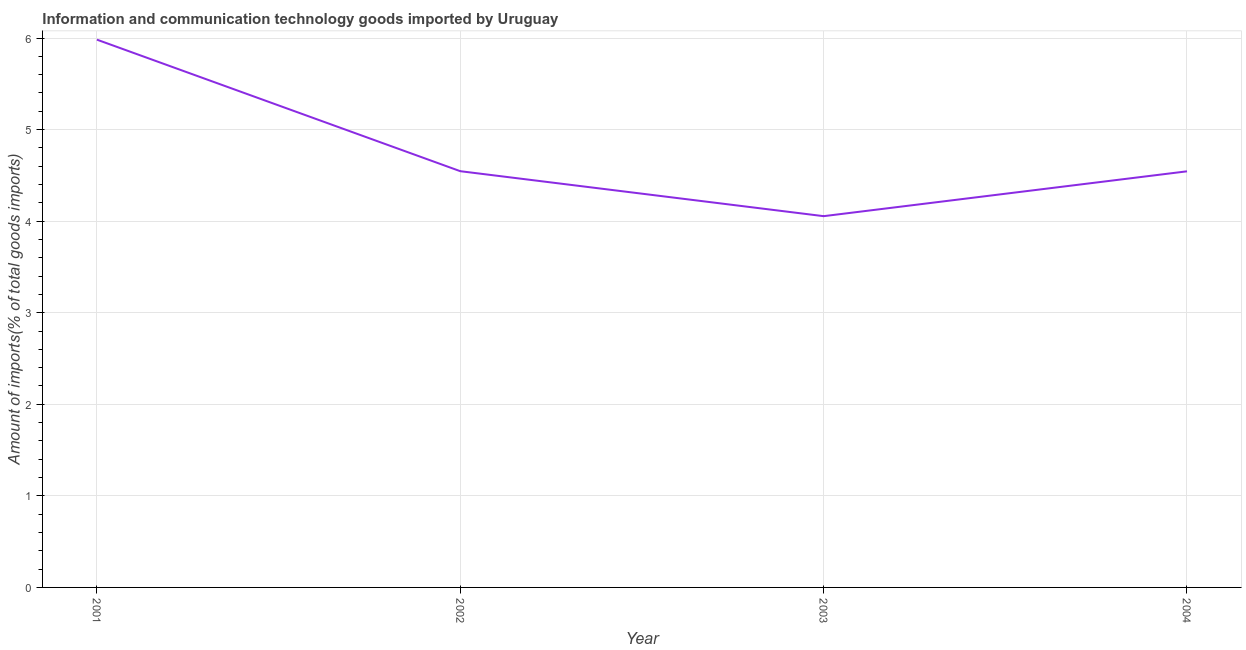What is the amount of ict goods imports in 2004?
Your response must be concise. 4.54. Across all years, what is the maximum amount of ict goods imports?
Give a very brief answer. 5.98. Across all years, what is the minimum amount of ict goods imports?
Your response must be concise. 4.05. In which year was the amount of ict goods imports minimum?
Make the answer very short. 2003. What is the sum of the amount of ict goods imports?
Make the answer very short. 19.13. What is the difference between the amount of ict goods imports in 2002 and 2004?
Your answer should be very brief. 0. What is the average amount of ict goods imports per year?
Ensure brevity in your answer.  4.78. What is the median amount of ict goods imports?
Keep it short and to the point. 4.54. In how many years, is the amount of ict goods imports greater than 4.4 %?
Your answer should be very brief. 3. What is the ratio of the amount of ict goods imports in 2001 to that in 2002?
Your answer should be compact. 1.32. Is the amount of ict goods imports in 2002 less than that in 2003?
Offer a very short reply. No. What is the difference between the highest and the second highest amount of ict goods imports?
Give a very brief answer. 1.44. What is the difference between the highest and the lowest amount of ict goods imports?
Provide a succinct answer. 1.93. In how many years, is the amount of ict goods imports greater than the average amount of ict goods imports taken over all years?
Keep it short and to the point. 1. How many lines are there?
Offer a very short reply. 1. How many years are there in the graph?
Offer a very short reply. 4. Does the graph contain any zero values?
Your answer should be very brief. No. What is the title of the graph?
Keep it short and to the point. Information and communication technology goods imported by Uruguay. What is the label or title of the X-axis?
Offer a terse response. Year. What is the label or title of the Y-axis?
Your response must be concise. Amount of imports(% of total goods imports). What is the Amount of imports(% of total goods imports) in 2001?
Provide a short and direct response. 5.98. What is the Amount of imports(% of total goods imports) of 2002?
Provide a succinct answer. 4.55. What is the Amount of imports(% of total goods imports) of 2003?
Your answer should be compact. 4.05. What is the Amount of imports(% of total goods imports) in 2004?
Your answer should be very brief. 4.54. What is the difference between the Amount of imports(% of total goods imports) in 2001 and 2002?
Ensure brevity in your answer.  1.44. What is the difference between the Amount of imports(% of total goods imports) in 2001 and 2003?
Make the answer very short. 1.93. What is the difference between the Amount of imports(% of total goods imports) in 2001 and 2004?
Offer a terse response. 1.44. What is the difference between the Amount of imports(% of total goods imports) in 2002 and 2003?
Keep it short and to the point. 0.49. What is the difference between the Amount of imports(% of total goods imports) in 2002 and 2004?
Make the answer very short. 0. What is the difference between the Amount of imports(% of total goods imports) in 2003 and 2004?
Provide a short and direct response. -0.49. What is the ratio of the Amount of imports(% of total goods imports) in 2001 to that in 2002?
Ensure brevity in your answer.  1.32. What is the ratio of the Amount of imports(% of total goods imports) in 2001 to that in 2003?
Ensure brevity in your answer.  1.48. What is the ratio of the Amount of imports(% of total goods imports) in 2001 to that in 2004?
Your response must be concise. 1.32. What is the ratio of the Amount of imports(% of total goods imports) in 2002 to that in 2003?
Provide a short and direct response. 1.12. What is the ratio of the Amount of imports(% of total goods imports) in 2002 to that in 2004?
Ensure brevity in your answer.  1. What is the ratio of the Amount of imports(% of total goods imports) in 2003 to that in 2004?
Give a very brief answer. 0.89. 